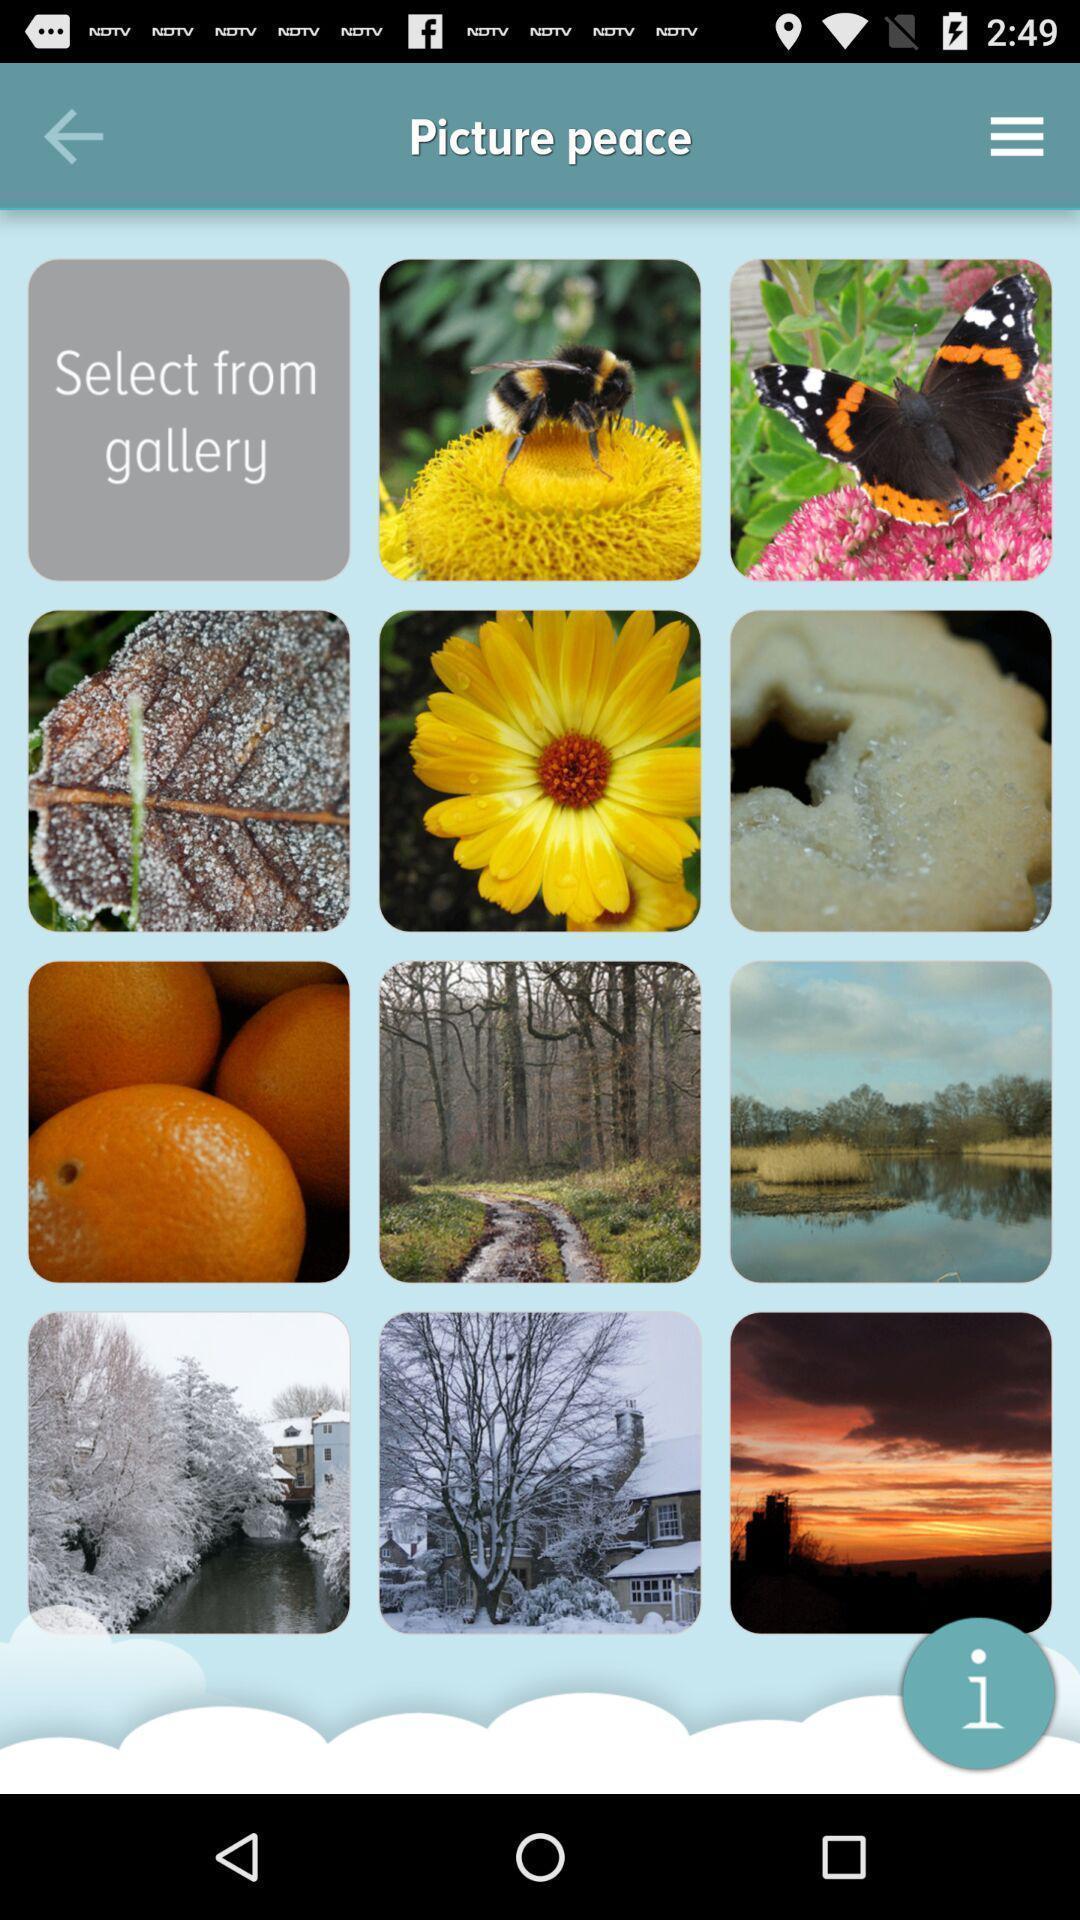Tell me about the visual elements in this screen capture. Screen showing different pictures. 